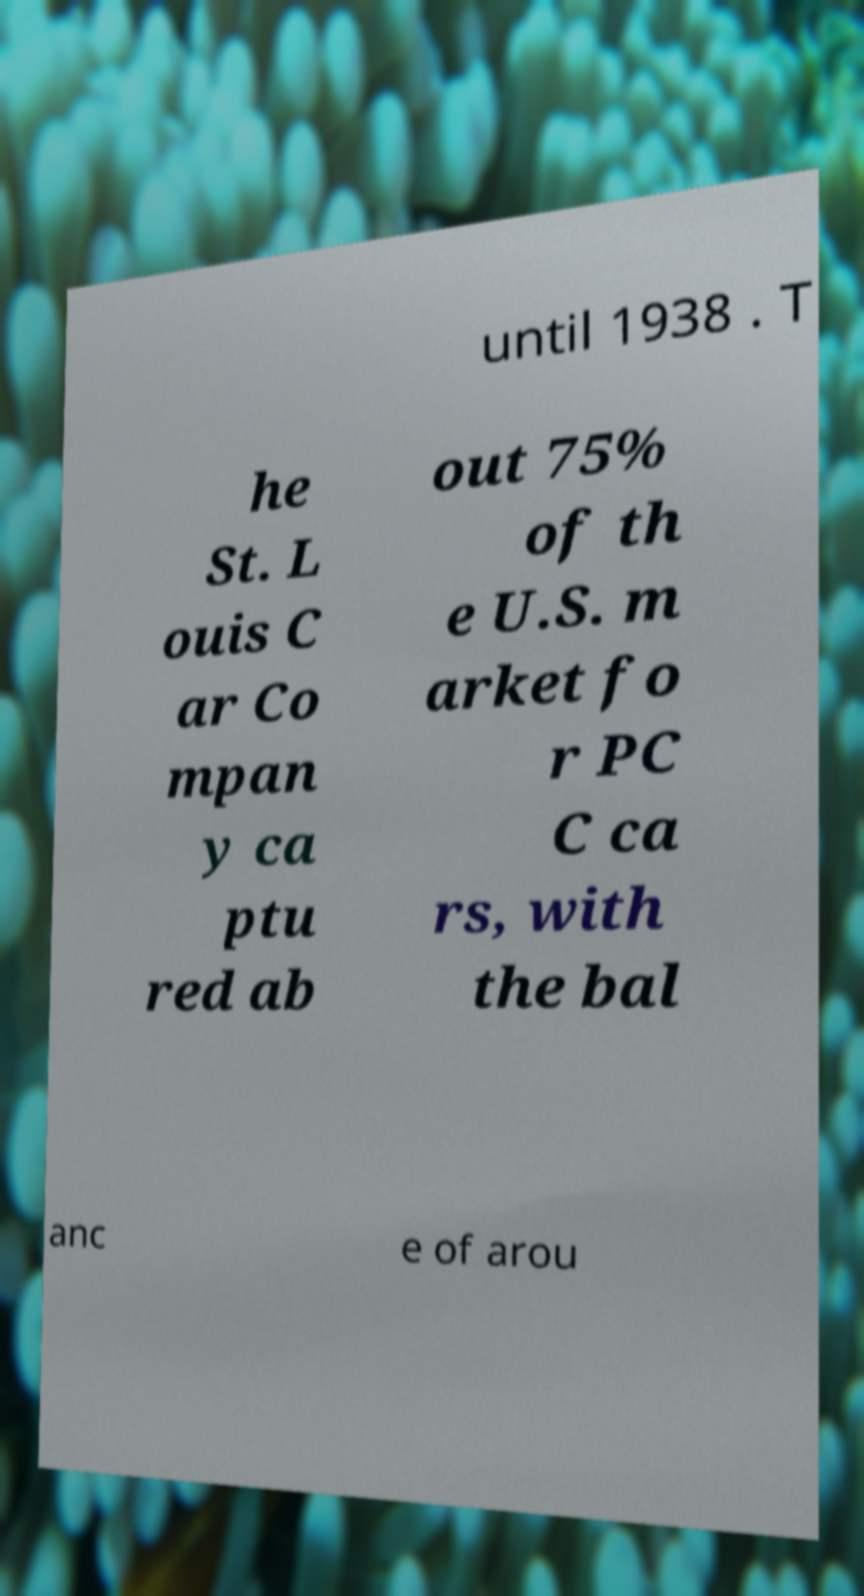What messages or text are displayed in this image? I need them in a readable, typed format. until 1938 . T he St. L ouis C ar Co mpan y ca ptu red ab out 75% of th e U.S. m arket fo r PC C ca rs, with the bal anc e of arou 